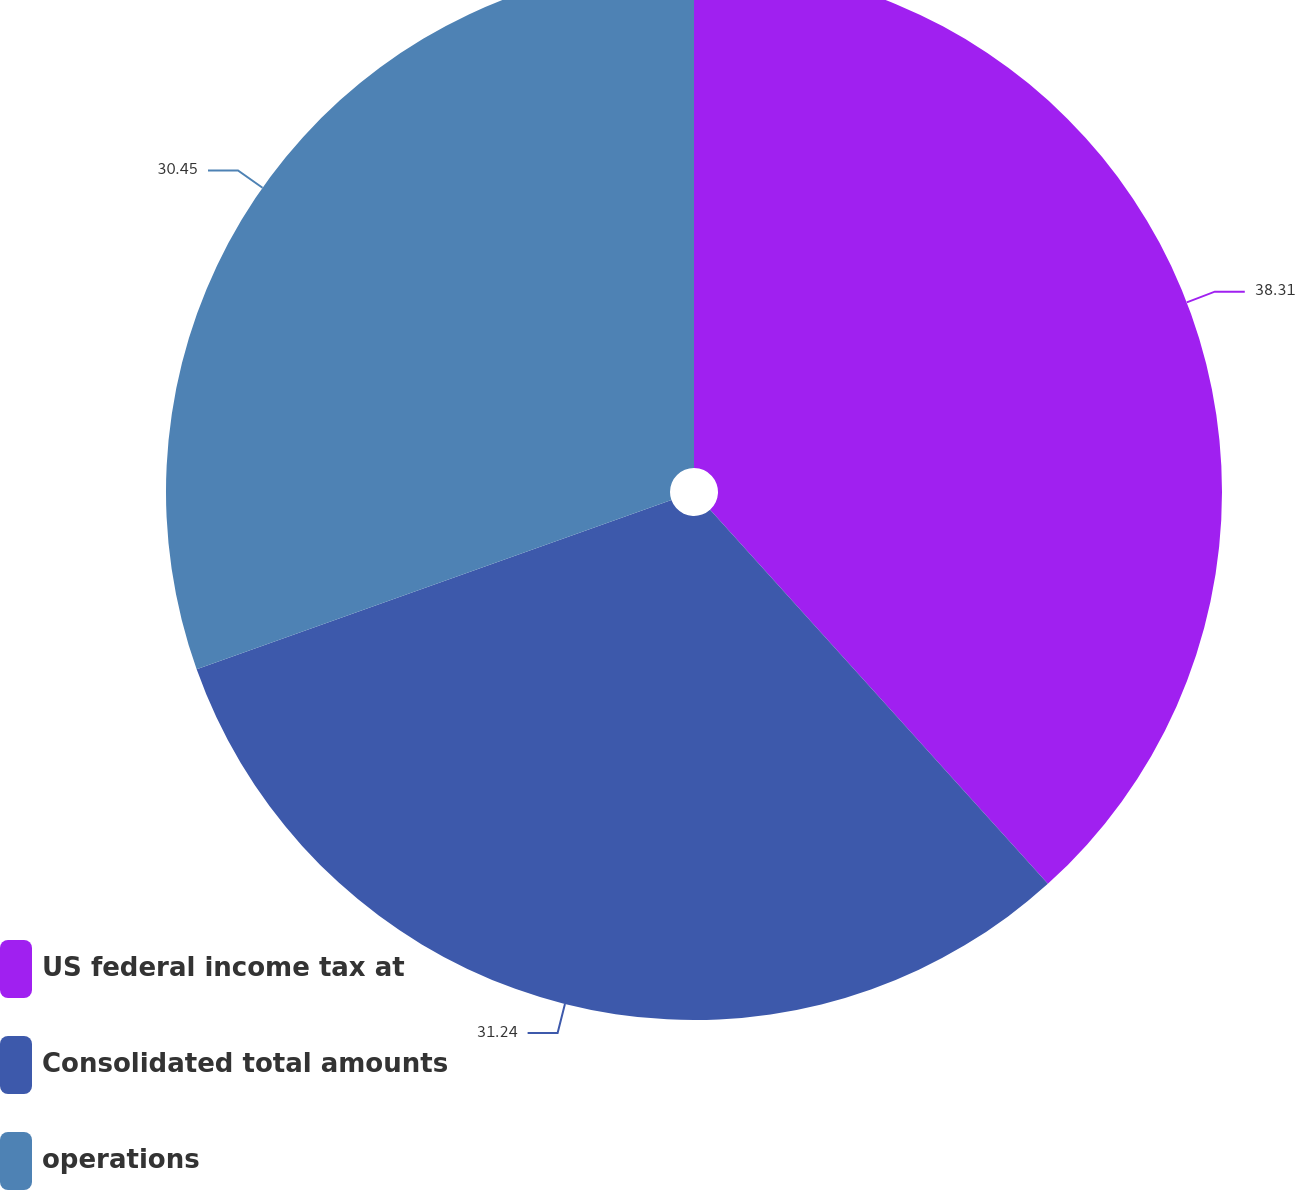Convert chart. <chart><loc_0><loc_0><loc_500><loc_500><pie_chart><fcel>US federal income tax at<fcel>Consolidated total amounts<fcel>operations<nl><fcel>38.31%<fcel>31.24%<fcel>30.45%<nl></chart> 